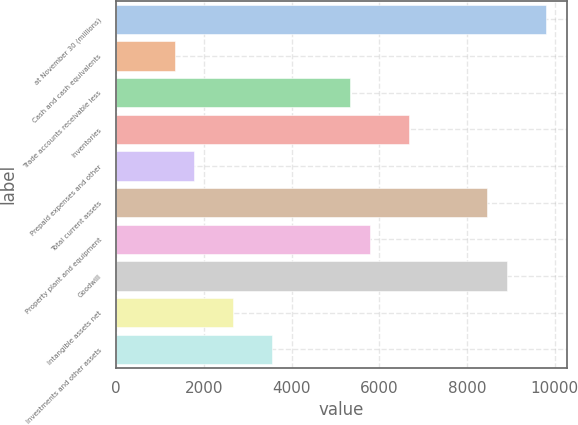Convert chart. <chart><loc_0><loc_0><loc_500><loc_500><bar_chart><fcel>at November 30 (millions)<fcel>Cash and cash equivalents<fcel>Trade accounts receivable less<fcel>Inventories<fcel>Prepaid expenses and other<fcel>Total current assets<fcel>Property plant and equipment<fcel>Goodwill<fcel>Intangible assets net<fcel>Investments and other assets<nl><fcel>9788.98<fcel>1335.12<fcel>5339.58<fcel>6674.4<fcel>1780.06<fcel>8454.16<fcel>5784.52<fcel>8899.1<fcel>2669.94<fcel>3559.82<nl></chart> 